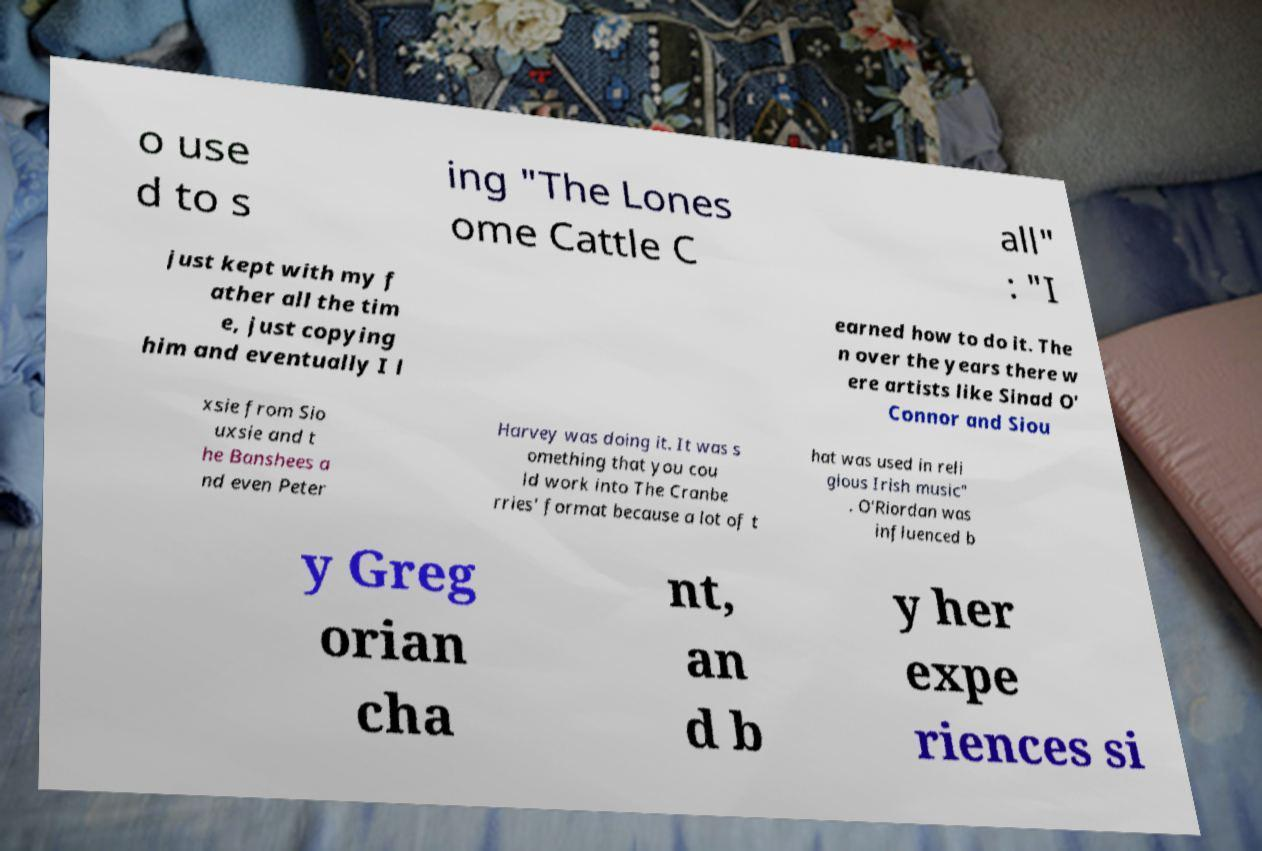Please identify and transcribe the text found in this image. o use d to s ing "The Lones ome Cattle C all" : "I just kept with my f ather all the tim e, just copying him and eventually I l earned how to do it. The n over the years there w ere artists like Sinad O' Connor and Siou xsie from Sio uxsie and t he Banshees a nd even Peter Harvey was doing it. It was s omething that you cou ld work into The Cranbe rries' format because a lot of t hat was used in reli gious Irish music" . O'Riordan was influenced b y Greg orian cha nt, an d b y her expe riences si 